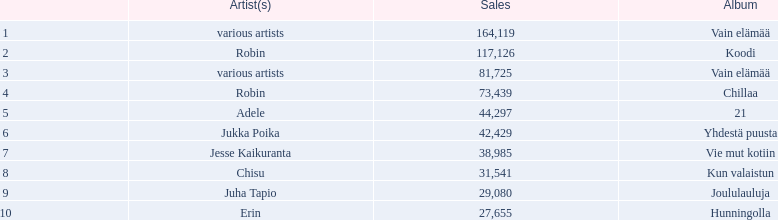What was the top selling album in this year? Vain elämää. 